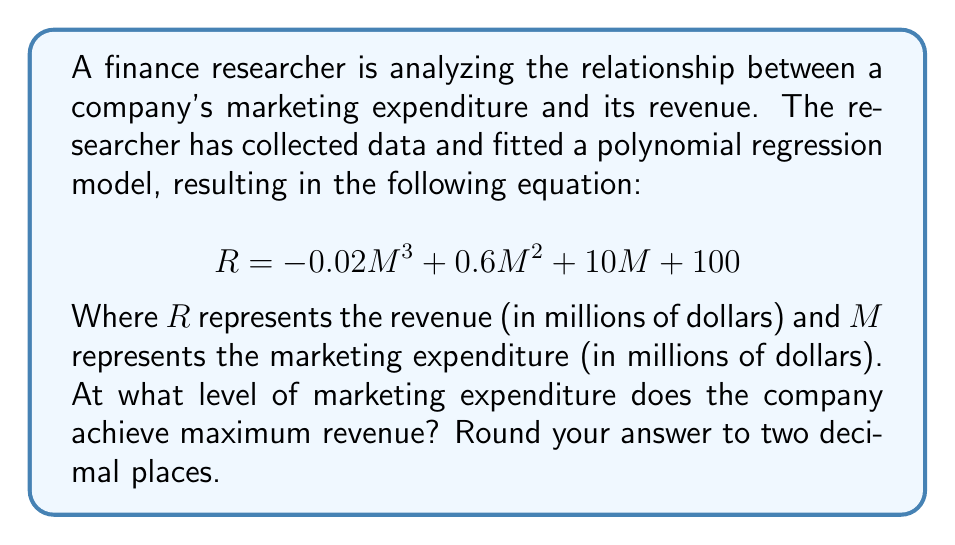Help me with this question. To find the maximum revenue, we need to determine the marketing expenditure where the derivative of the revenue function equals zero. This point represents the vertex of the polynomial curve.

1. First, let's find the derivative of the revenue function:
   $$\frac{dR}{dM} = -0.06M^2 + 1.2M + 10$$

2. Set the derivative equal to zero:
   $$-0.06M^2 + 1.2M + 10 = 0$$

3. This is a quadratic equation. We can solve it using the quadratic formula:
   $$M = \frac{-b \pm \sqrt{b^2 - 4ac}}{2a}$$
   
   Where $a = -0.06$, $b = 1.2$, and $c = 10$

4. Plugging in the values:
   $$M = \frac{-1.2 \pm \sqrt{1.2^2 - 4(-0.06)(10)}}{2(-0.06)}$$

5. Simplify:
   $$M = \frac{-1.2 \pm \sqrt{1.44 + 2.4}}{-0.12} = \frac{-1.2 \pm \sqrt{3.84}}{-0.12} = \frac{-1.2 \pm 1.96}{-0.12}$$

6. This gives us two solutions:
   $$M_1 = \frac{-1.2 + 1.96}{-0.12} = -6.33$$
   $$M_2 = \frac{-1.2 - 1.96}{-0.12} = 26.33$$

7. Since marketing expenditure cannot be negative, we discard the negative solution.

Therefore, the maximum revenue is achieved when the marketing expenditure is approximately 26.33 million dollars.
Answer: $26.33 million 